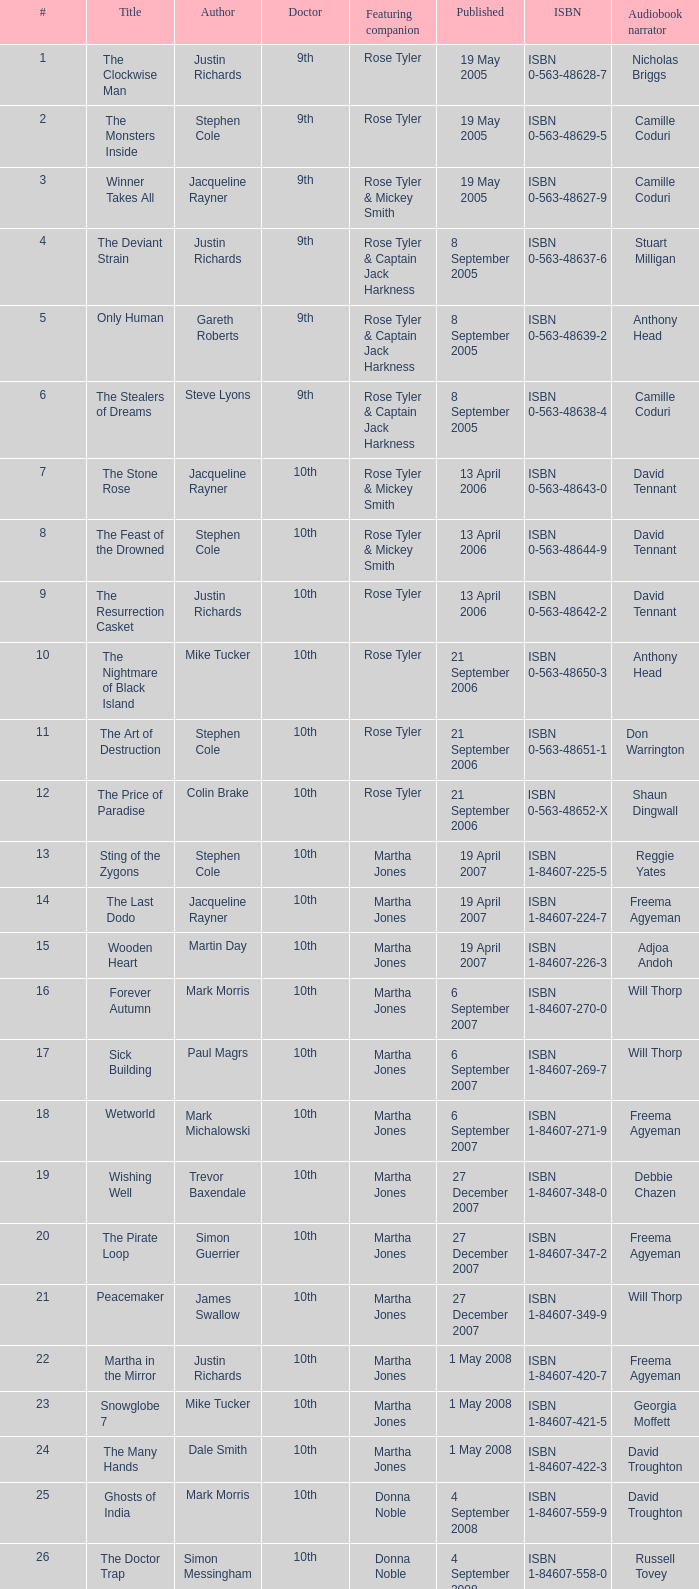Who are the featuring companions of number 3? Rose Tyler & Mickey Smith. 